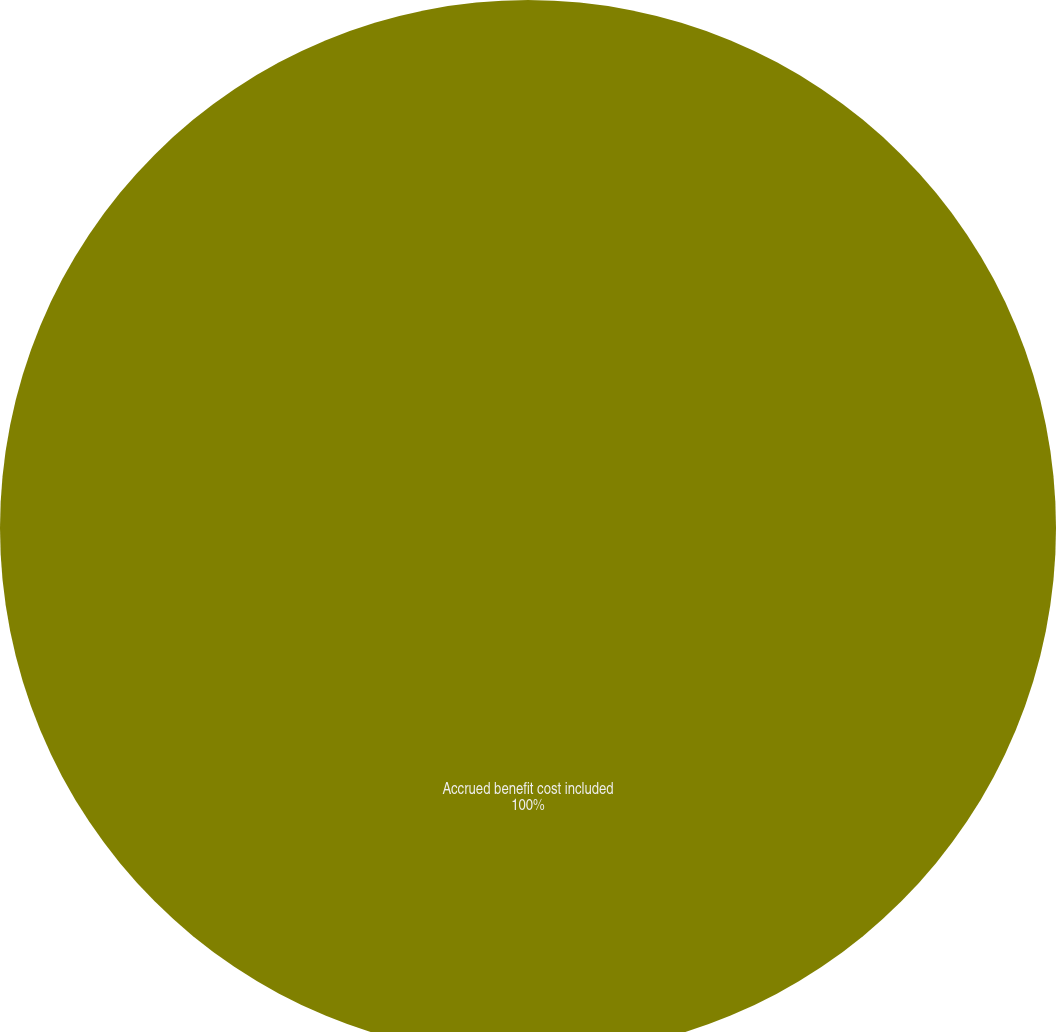<chart> <loc_0><loc_0><loc_500><loc_500><pie_chart><fcel>Accrued benefit cost included<nl><fcel>100.0%<nl></chart> 